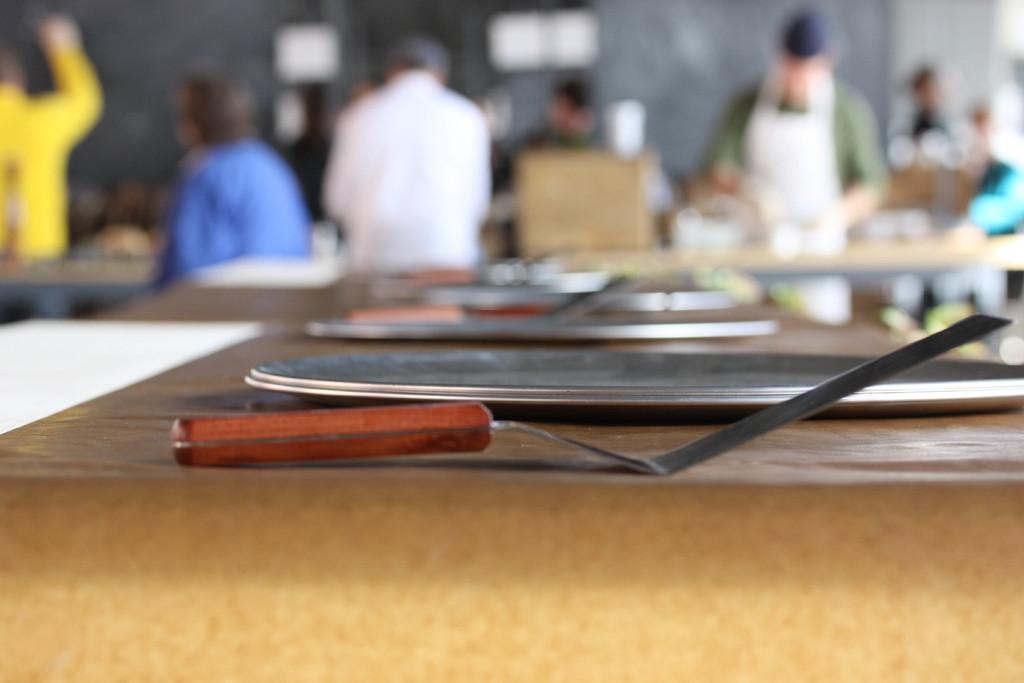What objects are on the table in the image? There are spoons and plates on the table in the image. Can you describe the people in the background of the image? Some people are standing, and some are sitting in the background of the image. How many people are visible in the background? The number of people is not specified, but there are both standing and sitting people present. What type of mist can be seen surrounding the people in the image? There is no mist present in the image; it features people in a background setting with no visible mist. 